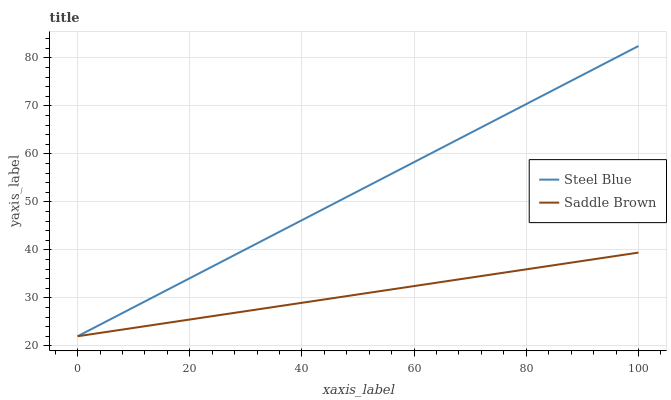Does Saddle Brown have the minimum area under the curve?
Answer yes or no. Yes. Does Steel Blue have the maximum area under the curve?
Answer yes or no. Yes. Does Saddle Brown have the maximum area under the curve?
Answer yes or no. No. Is Saddle Brown the smoothest?
Answer yes or no. Yes. Is Steel Blue the roughest?
Answer yes or no. Yes. Is Saddle Brown the roughest?
Answer yes or no. No. Does Steel Blue have the lowest value?
Answer yes or no. Yes. Does Steel Blue have the highest value?
Answer yes or no. Yes. Does Saddle Brown have the highest value?
Answer yes or no. No. Does Saddle Brown intersect Steel Blue?
Answer yes or no. Yes. Is Saddle Brown less than Steel Blue?
Answer yes or no. No. Is Saddle Brown greater than Steel Blue?
Answer yes or no. No. 